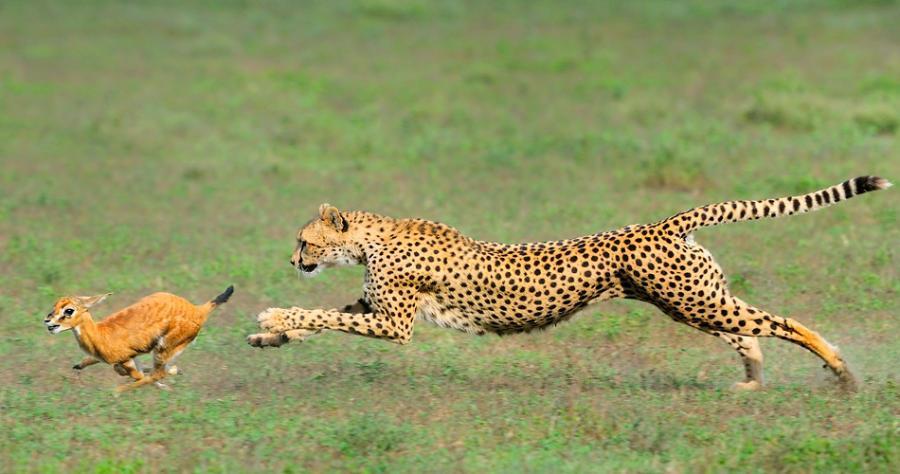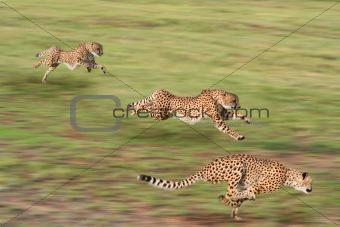The first image is the image on the left, the second image is the image on the right. Examine the images to the left and right. Is the description "An image shows at least one cheetah near an animal with curved horns." accurate? Answer yes or no. No. The first image is the image on the left, the second image is the image on the right. For the images displayed, is the sentence "An image shows one cheetah bounding with front paws extended." factually correct? Answer yes or no. Yes. The first image is the image on the left, the second image is the image on the right. Analyze the images presented: Is the assertion "There are four cheetas shown" valid? Answer yes or no. Yes. The first image is the image on the left, the second image is the image on the right. Considering the images on both sides, is "there are exactly three animals in the image on the right" valid? Answer yes or no. Yes. 